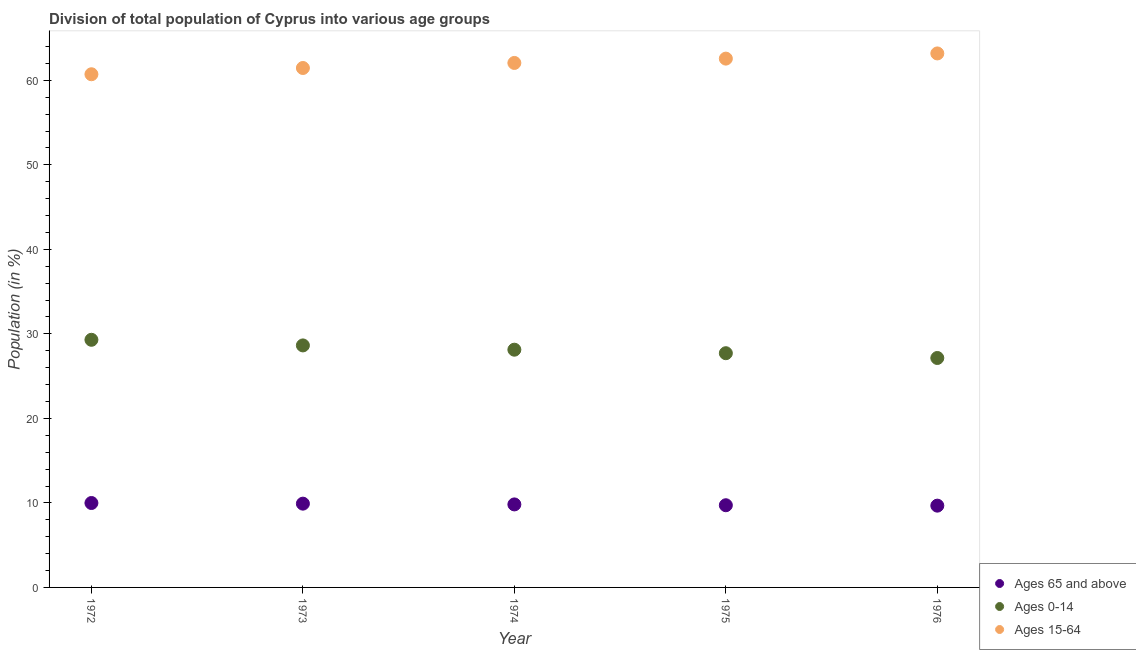Is the number of dotlines equal to the number of legend labels?
Your answer should be compact. Yes. What is the percentage of population within the age-group 15-64 in 1974?
Offer a very short reply. 62.05. Across all years, what is the maximum percentage of population within the age-group 15-64?
Provide a succinct answer. 63.18. Across all years, what is the minimum percentage of population within the age-group 0-14?
Offer a very short reply. 27.15. In which year was the percentage of population within the age-group 15-64 maximum?
Make the answer very short. 1976. In which year was the percentage of population within the age-group of 65 and above minimum?
Keep it short and to the point. 1976. What is the total percentage of population within the age-group 15-64 in the graph?
Give a very brief answer. 309.97. What is the difference between the percentage of population within the age-group 0-14 in 1972 and that in 1974?
Make the answer very short. 1.17. What is the difference between the percentage of population within the age-group 0-14 in 1972 and the percentage of population within the age-group 15-64 in 1973?
Offer a terse response. -32.16. What is the average percentage of population within the age-group 15-64 per year?
Your answer should be very brief. 61.99. In the year 1974, what is the difference between the percentage of population within the age-group of 65 and above and percentage of population within the age-group 0-14?
Make the answer very short. -18.31. What is the ratio of the percentage of population within the age-group 0-14 in 1972 to that in 1975?
Keep it short and to the point. 1.06. Is the percentage of population within the age-group 15-64 in 1973 less than that in 1976?
Offer a terse response. Yes. Is the difference between the percentage of population within the age-group 15-64 in 1974 and 1975 greater than the difference between the percentage of population within the age-group of 65 and above in 1974 and 1975?
Your response must be concise. No. What is the difference between the highest and the second highest percentage of population within the age-group 0-14?
Offer a terse response. 0.66. What is the difference between the highest and the lowest percentage of population within the age-group 15-64?
Provide a succinct answer. 2.46. Does the percentage of population within the age-group of 65 and above monotonically increase over the years?
Keep it short and to the point. No. Is the percentage of population within the age-group 0-14 strictly less than the percentage of population within the age-group of 65 and above over the years?
Provide a succinct answer. No. How many dotlines are there?
Give a very brief answer. 3. How many years are there in the graph?
Your response must be concise. 5. What is the difference between two consecutive major ticks on the Y-axis?
Ensure brevity in your answer.  10. Does the graph contain any zero values?
Give a very brief answer. No. Where does the legend appear in the graph?
Your answer should be very brief. Bottom right. How are the legend labels stacked?
Your answer should be compact. Vertical. What is the title of the graph?
Your response must be concise. Division of total population of Cyprus into various age groups
. What is the label or title of the X-axis?
Your response must be concise. Year. What is the label or title of the Y-axis?
Ensure brevity in your answer.  Population (in %). What is the Population (in %) in Ages 65 and above in 1972?
Keep it short and to the point. 9.99. What is the Population (in %) in Ages 0-14 in 1972?
Your answer should be compact. 29.3. What is the Population (in %) in Ages 15-64 in 1972?
Your response must be concise. 60.71. What is the Population (in %) in Ages 65 and above in 1973?
Keep it short and to the point. 9.91. What is the Population (in %) of Ages 0-14 in 1973?
Your response must be concise. 28.63. What is the Population (in %) of Ages 15-64 in 1973?
Your answer should be very brief. 61.46. What is the Population (in %) of Ages 65 and above in 1974?
Provide a short and direct response. 9.82. What is the Population (in %) in Ages 0-14 in 1974?
Ensure brevity in your answer.  28.13. What is the Population (in %) of Ages 15-64 in 1974?
Offer a very short reply. 62.05. What is the Population (in %) of Ages 65 and above in 1975?
Provide a short and direct response. 9.72. What is the Population (in %) of Ages 0-14 in 1975?
Offer a terse response. 27.71. What is the Population (in %) of Ages 15-64 in 1975?
Your answer should be compact. 62.56. What is the Population (in %) of Ages 65 and above in 1976?
Your answer should be very brief. 9.68. What is the Population (in %) of Ages 0-14 in 1976?
Provide a succinct answer. 27.15. What is the Population (in %) of Ages 15-64 in 1976?
Offer a very short reply. 63.18. Across all years, what is the maximum Population (in %) in Ages 65 and above?
Your answer should be very brief. 9.99. Across all years, what is the maximum Population (in %) of Ages 0-14?
Ensure brevity in your answer.  29.3. Across all years, what is the maximum Population (in %) of Ages 15-64?
Keep it short and to the point. 63.18. Across all years, what is the minimum Population (in %) in Ages 65 and above?
Keep it short and to the point. 9.68. Across all years, what is the minimum Population (in %) of Ages 0-14?
Ensure brevity in your answer.  27.15. Across all years, what is the minimum Population (in %) in Ages 15-64?
Offer a very short reply. 60.71. What is the total Population (in %) in Ages 65 and above in the graph?
Your answer should be very brief. 49.12. What is the total Population (in %) of Ages 0-14 in the graph?
Offer a terse response. 140.92. What is the total Population (in %) in Ages 15-64 in the graph?
Provide a succinct answer. 309.97. What is the difference between the Population (in %) of Ages 65 and above in 1972 and that in 1973?
Offer a terse response. 0.08. What is the difference between the Population (in %) in Ages 0-14 in 1972 and that in 1973?
Make the answer very short. 0.66. What is the difference between the Population (in %) of Ages 15-64 in 1972 and that in 1973?
Your answer should be compact. -0.74. What is the difference between the Population (in %) in Ages 0-14 in 1972 and that in 1974?
Offer a very short reply. 1.17. What is the difference between the Population (in %) of Ages 15-64 in 1972 and that in 1974?
Ensure brevity in your answer.  -1.34. What is the difference between the Population (in %) in Ages 65 and above in 1972 and that in 1975?
Give a very brief answer. 0.26. What is the difference between the Population (in %) of Ages 0-14 in 1972 and that in 1975?
Give a very brief answer. 1.59. What is the difference between the Population (in %) of Ages 15-64 in 1972 and that in 1975?
Your answer should be compact. -1.85. What is the difference between the Population (in %) of Ages 65 and above in 1972 and that in 1976?
Provide a succinct answer. 0.31. What is the difference between the Population (in %) in Ages 0-14 in 1972 and that in 1976?
Provide a short and direct response. 2.15. What is the difference between the Population (in %) in Ages 15-64 in 1972 and that in 1976?
Ensure brevity in your answer.  -2.46. What is the difference between the Population (in %) in Ages 65 and above in 1973 and that in 1974?
Your answer should be compact. 0.09. What is the difference between the Population (in %) in Ages 0-14 in 1973 and that in 1974?
Provide a short and direct response. 0.51. What is the difference between the Population (in %) of Ages 15-64 in 1973 and that in 1974?
Your answer should be compact. -0.6. What is the difference between the Population (in %) in Ages 65 and above in 1973 and that in 1975?
Your answer should be compact. 0.19. What is the difference between the Population (in %) of Ages 0-14 in 1973 and that in 1975?
Give a very brief answer. 0.92. What is the difference between the Population (in %) in Ages 15-64 in 1973 and that in 1975?
Your response must be concise. -1.11. What is the difference between the Population (in %) in Ages 65 and above in 1973 and that in 1976?
Keep it short and to the point. 0.24. What is the difference between the Population (in %) of Ages 0-14 in 1973 and that in 1976?
Make the answer very short. 1.49. What is the difference between the Population (in %) in Ages 15-64 in 1973 and that in 1976?
Your answer should be very brief. -1.72. What is the difference between the Population (in %) in Ages 65 and above in 1974 and that in 1975?
Offer a very short reply. 0.1. What is the difference between the Population (in %) of Ages 0-14 in 1974 and that in 1975?
Ensure brevity in your answer.  0.42. What is the difference between the Population (in %) of Ages 15-64 in 1974 and that in 1975?
Make the answer very short. -0.51. What is the difference between the Population (in %) of Ages 65 and above in 1974 and that in 1976?
Your answer should be compact. 0.14. What is the difference between the Population (in %) of Ages 0-14 in 1974 and that in 1976?
Your answer should be very brief. 0.98. What is the difference between the Population (in %) in Ages 15-64 in 1974 and that in 1976?
Keep it short and to the point. -1.13. What is the difference between the Population (in %) of Ages 65 and above in 1975 and that in 1976?
Offer a terse response. 0.05. What is the difference between the Population (in %) of Ages 0-14 in 1975 and that in 1976?
Provide a short and direct response. 0.57. What is the difference between the Population (in %) in Ages 15-64 in 1975 and that in 1976?
Provide a short and direct response. -0.61. What is the difference between the Population (in %) in Ages 65 and above in 1972 and the Population (in %) in Ages 0-14 in 1973?
Provide a short and direct response. -18.65. What is the difference between the Population (in %) in Ages 65 and above in 1972 and the Population (in %) in Ages 15-64 in 1973?
Give a very brief answer. -51.47. What is the difference between the Population (in %) in Ages 0-14 in 1972 and the Population (in %) in Ages 15-64 in 1973?
Your response must be concise. -32.16. What is the difference between the Population (in %) of Ages 65 and above in 1972 and the Population (in %) of Ages 0-14 in 1974?
Offer a very short reply. -18.14. What is the difference between the Population (in %) in Ages 65 and above in 1972 and the Population (in %) in Ages 15-64 in 1974?
Provide a short and direct response. -52.06. What is the difference between the Population (in %) in Ages 0-14 in 1972 and the Population (in %) in Ages 15-64 in 1974?
Make the answer very short. -32.75. What is the difference between the Population (in %) of Ages 65 and above in 1972 and the Population (in %) of Ages 0-14 in 1975?
Ensure brevity in your answer.  -17.72. What is the difference between the Population (in %) of Ages 65 and above in 1972 and the Population (in %) of Ages 15-64 in 1975?
Provide a succinct answer. -52.58. What is the difference between the Population (in %) of Ages 0-14 in 1972 and the Population (in %) of Ages 15-64 in 1975?
Offer a very short reply. -33.27. What is the difference between the Population (in %) of Ages 65 and above in 1972 and the Population (in %) of Ages 0-14 in 1976?
Offer a terse response. -17.16. What is the difference between the Population (in %) in Ages 65 and above in 1972 and the Population (in %) in Ages 15-64 in 1976?
Provide a succinct answer. -53.19. What is the difference between the Population (in %) in Ages 0-14 in 1972 and the Population (in %) in Ages 15-64 in 1976?
Offer a very short reply. -33.88. What is the difference between the Population (in %) in Ages 65 and above in 1973 and the Population (in %) in Ages 0-14 in 1974?
Your answer should be very brief. -18.22. What is the difference between the Population (in %) of Ages 65 and above in 1973 and the Population (in %) of Ages 15-64 in 1974?
Your answer should be very brief. -52.14. What is the difference between the Population (in %) of Ages 0-14 in 1973 and the Population (in %) of Ages 15-64 in 1974?
Your response must be concise. -33.42. What is the difference between the Population (in %) of Ages 65 and above in 1973 and the Population (in %) of Ages 0-14 in 1975?
Offer a terse response. -17.8. What is the difference between the Population (in %) in Ages 65 and above in 1973 and the Population (in %) in Ages 15-64 in 1975?
Make the answer very short. -52.65. What is the difference between the Population (in %) in Ages 0-14 in 1973 and the Population (in %) in Ages 15-64 in 1975?
Provide a short and direct response. -33.93. What is the difference between the Population (in %) in Ages 65 and above in 1973 and the Population (in %) in Ages 0-14 in 1976?
Ensure brevity in your answer.  -17.23. What is the difference between the Population (in %) in Ages 65 and above in 1973 and the Population (in %) in Ages 15-64 in 1976?
Provide a succinct answer. -53.27. What is the difference between the Population (in %) in Ages 0-14 in 1973 and the Population (in %) in Ages 15-64 in 1976?
Your response must be concise. -34.55. What is the difference between the Population (in %) of Ages 65 and above in 1974 and the Population (in %) of Ages 0-14 in 1975?
Offer a very short reply. -17.89. What is the difference between the Population (in %) in Ages 65 and above in 1974 and the Population (in %) in Ages 15-64 in 1975?
Offer a very short reply. -52.74. What is the difference between the Population (in %) of Ages 0-14 in 1974 and the Population (in %) of Ages 15-64 in 1975?
Keep it short and to the point. -34.44. What is the difference between the Population (in %) in Ages 65 and above in 1974 and the Population (in %) in Ages 0-14 in 1976?
Offer a very short reply. -17.33. What is the difference between the Population (in %) in Ages 65 and above in 1974 and the Population (in %) in Ages 15-64 in 1976?
Give a very brief answer. -53.36. What is the difference between the Population (in %) in Ages 0-14 in 1974 and the Population (in %) in Ages 15-64 in 1976?
Give a very brief answer. -35.05. What is the difference between the Population (in %) of Ages 65 and above in 1975 and the Population (in %) of Ages 0-14 in 1976?
Provide a short and direct response. -17.42. What is the difference between the Population (in %) in Ages 65 and above in 1975 and the Population (in %) in Ages 15-64 in 1976?
Provide a succinct answer. -53.45. What is the difference between the Population (in %) of Ages 0-14 in 1975 and the Population (in %) of Ages 15-64 in 1976?
Offer a very short reply. -35.47. What is the average Population (in %) in Ages 65 and above per year?
Provide a succinct answer. 9.82. What is the average Population (in %) in Ages 0-14 per year?
Make the answer very short. 28.18. What is the average Population (in %) in Ages 15-64 per year?
Offer a very short reply. 61.99. In the year 1972, what is the difference between the Population (in %) in Ages 65 and above and Population (in %) in Ages 0-14?
Make the answer very short. -19.31. In the year 1972, what is the difference between the Population (in %) in Ages 65 and above and Population (in %) in Ages 15-64?
Your answer should be very brief. -50.73. In the year 1972, what is the difference between the Population (in %) of Ages 0-14 and Population (in %) of Ages 15-64?
Provide a succinct answer. -31.42. In the year 1973, what is the difference between the Population (in %) in Ages 65 and above and Population (in %) in Ages 0-14?
Offer a terse response. -18.72. In the year 1973, what is the difference between the Population (in %) in Ages 65 and above and Population (in %) in Ages 15-64?
Offer a very short reply. -51.54. In the year 1973, what is the difference between the Population (in %) in Ages 0-14 and Population (in %) in Ages 15-64?
Your answer should be compact. -32.82. In the year 1974, what is the difference between the Population (in %) in Ages 65 and above and Population (in %) in Ages 0-14?
Your answer should be very brief. -18.31. In the year 1974, what is the difference between the Population (in %) of Ages 65 and above and Population (in %) of Ages 15-64?
Your response must be concise. -52.23. In the year 1974, what is the difference between the Population (in %) of Ages 0-14 and Population (in %) of Ages 15-64?
Your answer should be very brief. -33.92. In the year 1975, what is the difference between the Population (in %) in Ages 65 and above and Population (in %) in Ages 0-14?
Give a very brief answer. -17.99. In the year 1975, what is the difference between the Population (in %) in Ages 65 and above and Population (in %) in Ages 15-64?
Offer a very short reply. -52.84. In the year 1975, what is the difference between the Population (in %) of Ages 0-14 and Population (in %) of Ages 15-64?
Your answer should be compact. -34.85. In the year 1976, what is the difference between the Population (in %) in Ages 65 and above and Population (in %) in Ages 0-14?
Make the answer very short. -17.47. In the year 1976, what is the difference between the Population (in %) of Ages 65 and above and Population (in %) of Ages 15-64?
Provide a succinct answer. -53.5. In the year 1976, what is the difference between the Population (in %) in Ages 0-14 and Population (in %) in Ages 15-64?
Provide a succinct answer. -36.03. What is the ratio of the Population (in %) in Ages 65 and above in 1972 to that in 1973?
Offer a terse response. 1.01. What is the ratio of the Population (in %) in Ages 0-14 in 1972 to that in 1973?
Provide a short and direct response. 1.02. What is the ratio of the Population (in %) of Ages 15-64 in 1972 to that in 1973?
Provide a succinct answer. 0.99. What is the ratio of the Population (in %) in Ages 65 and above in 1972 to that in 1974?
Make the answer very short. 1.02. What is the ratio of the Population (in %) of Ages 0-14 in 1972 to that in 1974?
Provide a succinct answer. 1.04. What is the ratio of the Population (in %) in Ages 15-64 in 1972 to that in 1974?
Your response must be concise. 0.98. What is the ratio of the Population (in %) in Ages 65 and above in 1972 to that in 1975?
Provide a succinct answer. 1.03. What is the ratio of the Population (in %) in Ages 0-14 in 1972 to that in 1975?
Offer a very short reply. 1.06. What is the ratio of the Population (in %) in Ages 15-64 in 1972 to that in 1975?
Your response must be concise. 0.97. What is the ratio of the Population (in %) of Ages 65 and above in 1972 to that in 1976?
Provide a succinct answer. 1.03. What is the ratio of the Population (in %) of Ages 0-14 in 1972 to that in 1976?
Ensure brevity in your answer.  1.08. What is the ratio of the Population (in %) in Ages 15-64 in 1972 to that in 1976?
Provide a succinct answer. 0.96. What is the ratio of the Population (in %) in Ages 65 and above in 1973 to that in 1974?
Offer a terse response. 1.01. What is the ratio of the Population (in %) in Ages 0-14 in 1973 to that in 1974?
Ensure brevity in your answer.  1.02. What is the ratio of the Population (in %) in Ages 65 and above in 1973 to that in 1975?
Keep it short and to the point. 1.02. What is the ratio of the Population (in %) in Ages 0-14 in 1973 to that in 1975?
Your response must be concise. 1.03. What is the ratio of the Population (in %) of Ages 15-64 in 1973 to that in 1975?
Your answer should be compact. 0.98. What is the ratio of the Population (in %) of Ages 65 and above in 1973 to that in 1976?
Your answer should be compact. 1.02. What is the ratio of the Population (in %) in Ages 0-14 in 1973 to that in 1976?
Provide a short and direct response. 1.05. What is the ratio of the Population (in %) in Ages 15-64 in 1973 to that in 1976?
Offer a terse response. 0.97. What is the ratio of the Population (in %) of Ages 65 and above in 1974 to that in 1976?
Offer a very short reply. 1.01. What is the ratio of the Population (in %) of Ages 0-14 in 1974 to that in 1976?
Offer a very short reply. 1.04. What is the ratio of the Population (in %) of Ages 15-64 in 1974 to that in 1976?
Ensure brevity in your answer.  0.98. What is the ratio of the Population (in %) of Ages 0-14 in 1975 to that in 1976?
Offer a very short reply. 1.02. What is the ratio of the Population (in %) of Ages 15-64 in 1975 to that in 1976?
Your answer should be very brief. 0.99. What is the difference between the highest and the second highest Population (in %) in Ages 65 and above?
Make the answer very short. 0.08. What is the difference between the highest and the second highest Population (in %) of Ages 0-14?
Offer a terse response. 0.66. What is the difference between the highest and the second highest Population (in %) of Ages 15-64?
Give a very brief answer. 0.61. What is the difference between the highest and the lowest Population (in %) of Ages 65 and above?
Offer a terse response. 0.31. What is the difference between the highest and the lowest Population (in %) of Ages 0-14?
Offer a very short reply. 2.15. What is the difference between the highest and the lowest Population (in %) in Ages 15-64?
Your response must be concise. 2.46. 